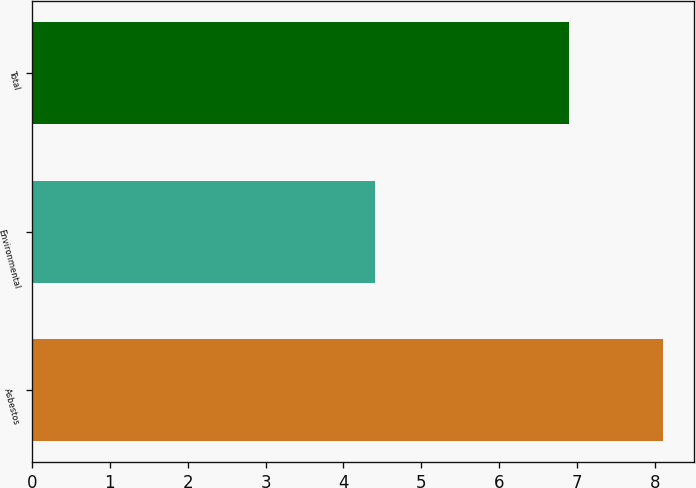Convert chart. <chart><loc_0><loc_0><loc_500><loc_500><bar_chart><fcel>Asbestos<fcel>Environmental<fcel>Total<nl><fcel>8.1<fcel>4.4<fcel>6.9<nl></chart> 